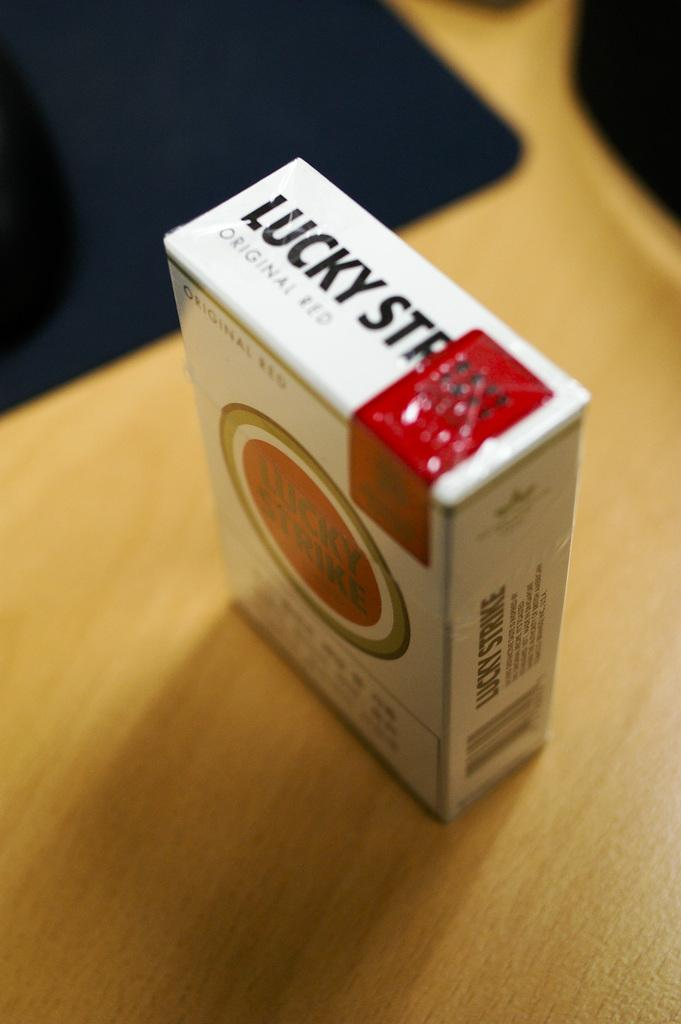<image>
Describe the image concisely. A box of Lucky Strikes contains original red cigarettes. 